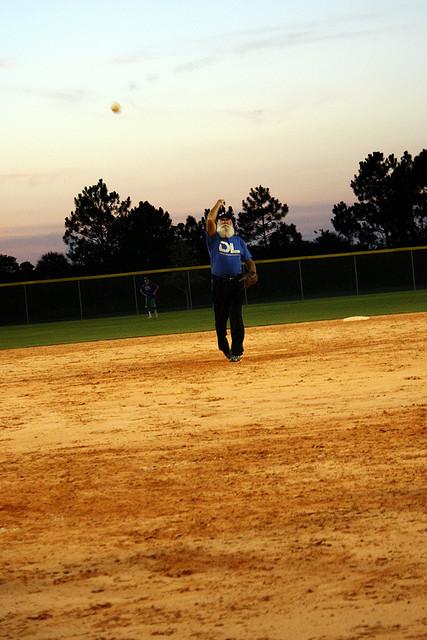What color shirt is he wearing?
Quick response, please. Blue. Is it sunny?
Keep it brief. Yes. Is this player in the infield or outfield?
Concise answer only. Infield. 